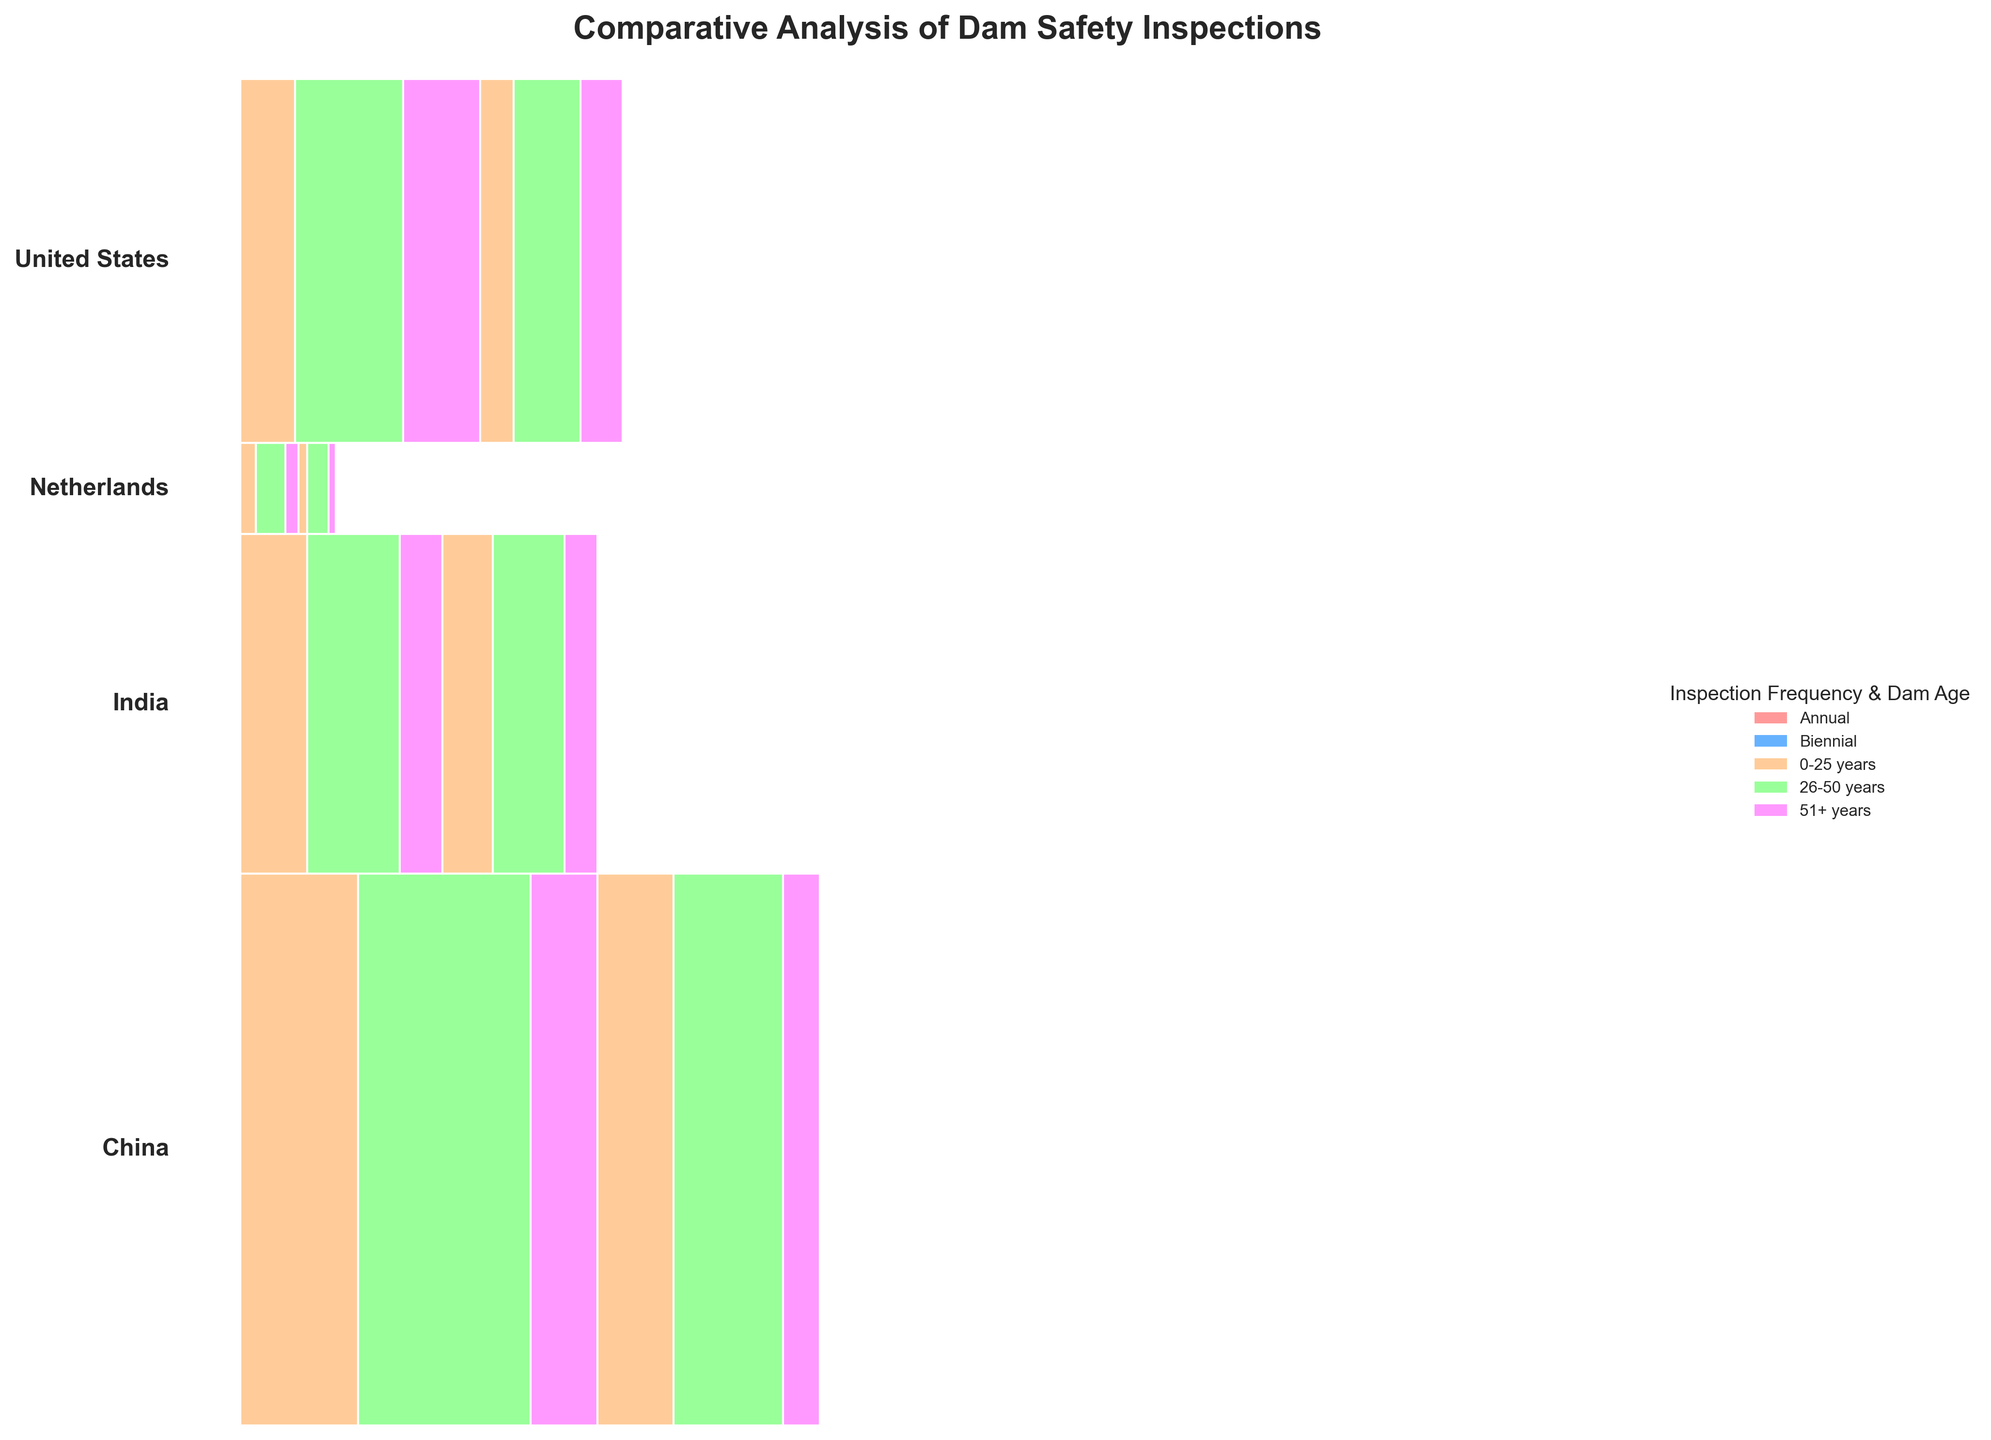How many countries are compared in the plot? The plot includes sections for each country, and each country's section is color-coded. By counting the number of distinct color blocks, we can determine the number of countries compared in the plot.
Answer: 4 Which country has the fewest dams inspected annually in the 51+ years age group? First, find the sections representing annual inspections for the 51+ years age group in each country's part of the plot. Then, compare their sizes. The Netherlands has the smallest portion in that age group.
Answer: Netherlands What is the total proportion of biennial inspections for dams in India? Look for the sections representing biennial inspections within the India part of the plot. Sum the portions for all age groups (0-25, 26-50, 51+ years) within the biennial inspections for India. Visual estimation shows that the combined proportion for biennial inspections is less than half of India's section.
Answer: About 50% Which dam age group in China has the largest proportion of annual inspections? Observe the size of the annual inspection sections for the 0-25, 26-50, and 51+ year groups in the China part of the plot. The 26-50 years group has the largest section.
Answer: 26-50 years How do the proportions of biennial inspections for dams aged 0-25 years compare between the United States and China? Compare the sizes of the sections for biennial inspections of 0-25 year dams between the United States and China. Visual estimation shows that the section for China (201) is larger than that for the United States (89).
Answer: China > United States Which inspection frequency is more predominant in the Netherlands for dams aged 26-50 years? Look at the 26-50 years sections within both annual and biennial frequencies in the Netherlands part of the plot. The size of the section for annual inspections (78) is larger than that for biennial inspections (56).
Answer: Annual What proportion of dams in the United States is inspected annually, across all ages? Identify the total sections of the United States' partition that represent annual inspections and add them up. Visual inspection suggests the total annual inspections (145+287+203) in the United States form the majority proportion.
Answer: Majority How does the proportion of dams aged 51+ years in India inspected biennially compare to those in the Netherlands inspected biennially? Compare the size of the biennial inspection sections for 51+ year dams in India (87) and the Netherlands (19). The section for India is notably larger.
Answer: India > Netherlands 